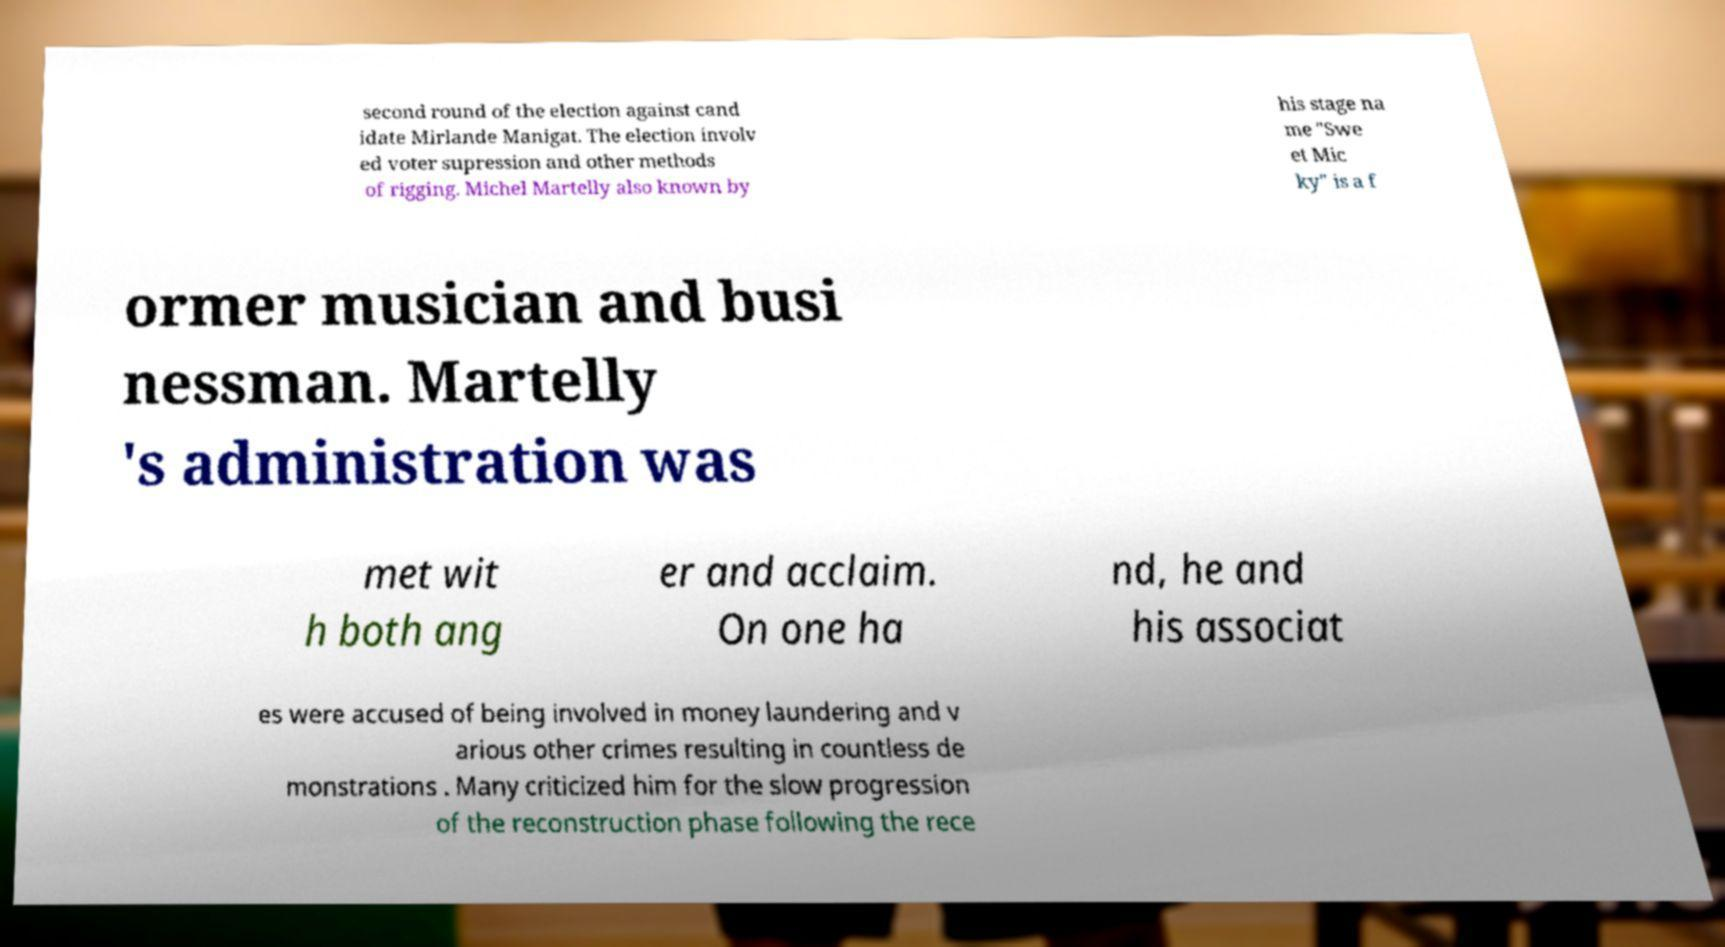There's text embedded in this image that I need extracted. Can you transcribe it verbatim? second round of the election against cand idate Mirlande Manigat. The election involv ed voter supression and other methods of rigging. Michel Martelly also known by his stage na me "Swe et Mic ky" is a f ormer musician and busi nessman. Martelly 's administration was met wit h both ang er and acclaim. On one ha nd, he and his associat es were accused of being involved in money laundering and v arious other crimes resulting in countless de monstrations . Many criticized him for the slow progression of the reconstruction phase following the rece 